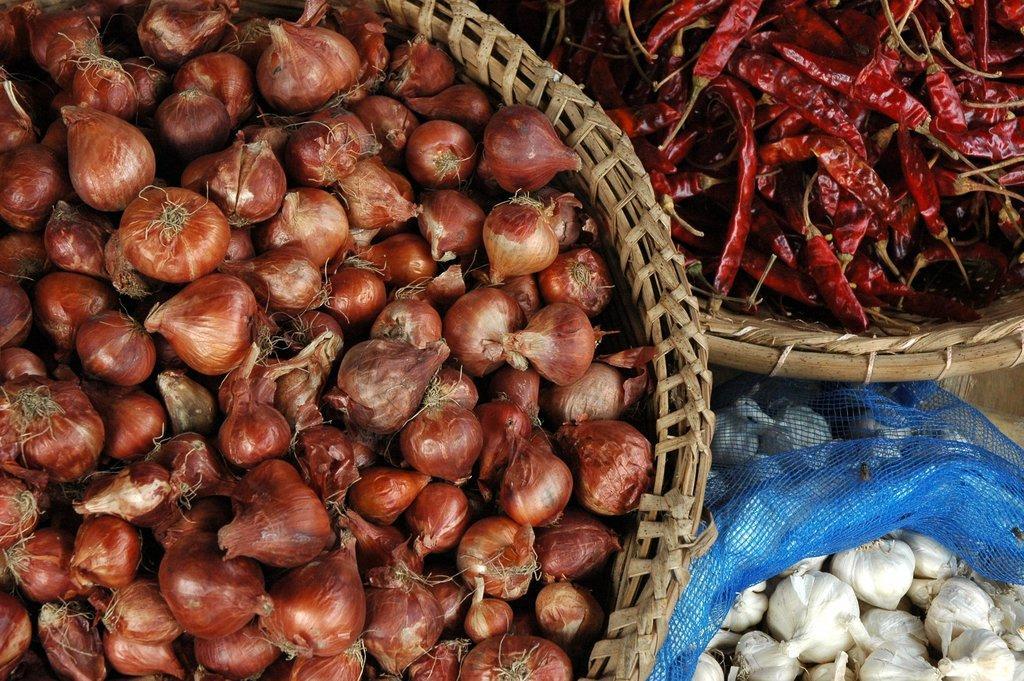Can you describe this image briefly? In the picture we can see a basket full of onions, and one basket full of red chilies and beside it we can see a blue color bag with full of ginger. 